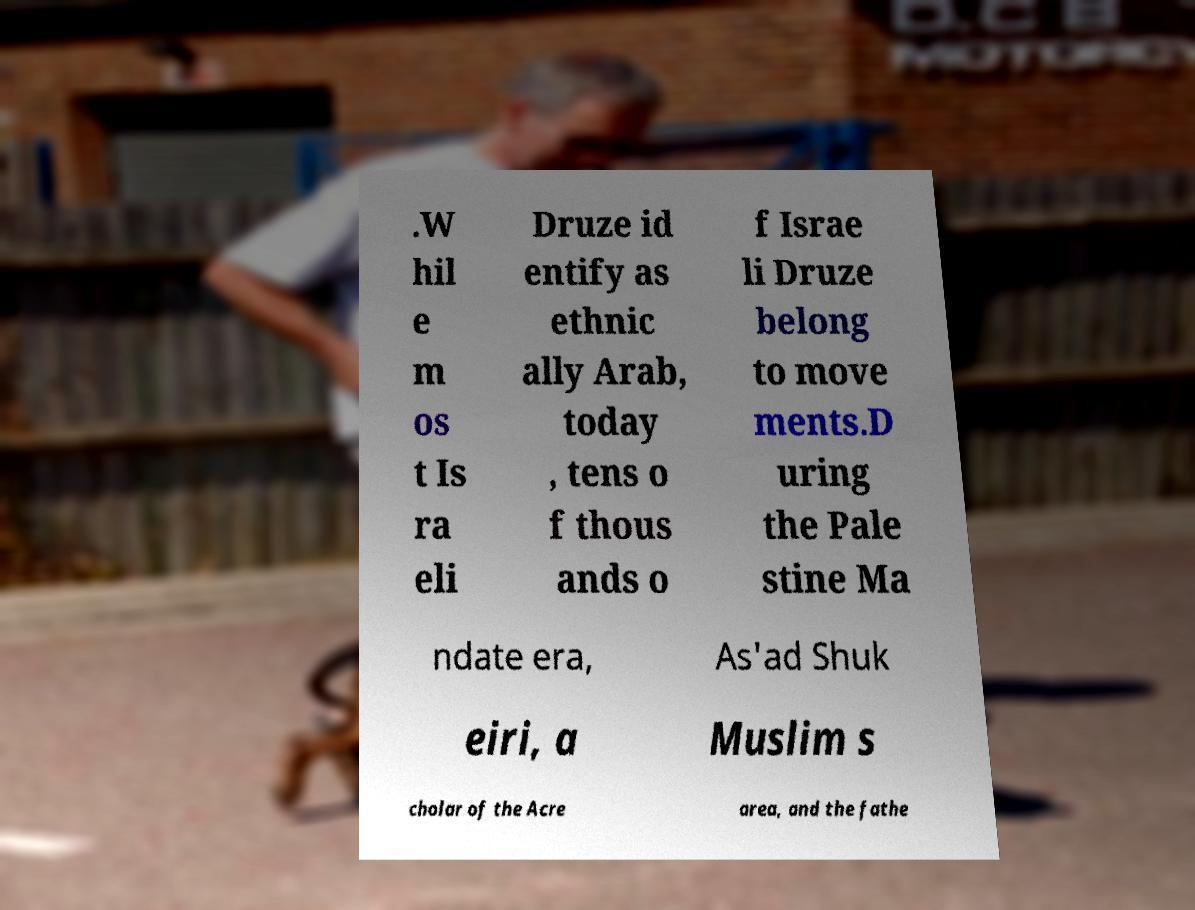Please read and relay the text visible in this image. What does it say? .W hil e m os t Is ra eli Druze id entify as ethnic ally Arab, today , tens o f thous ands o f Israe li Druze belong to move ments.D uring the Pale stine Ma ndate era, As'ad Shuk eiri, a Muslim s cholar of the Acre area, and the fathe 